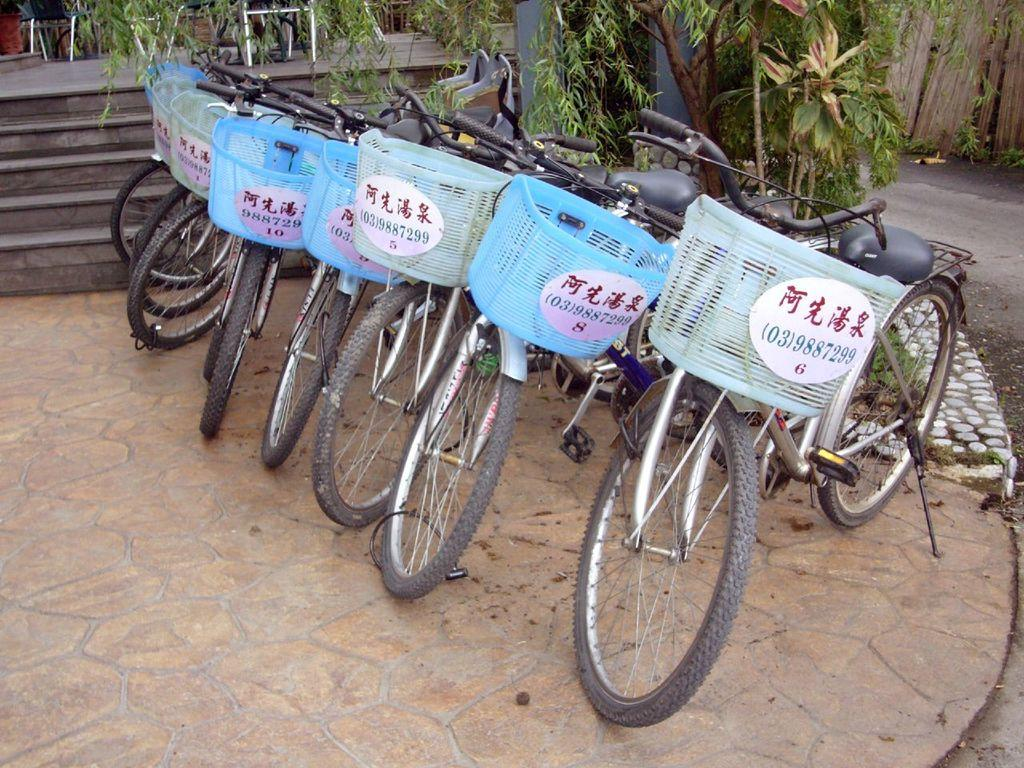What type of vehicles are present in the image? There are bicycles in the image. What is unique about the bicycles in the image? The bicycles have text on the baskets. What type of natural elements can be seen in the image? There are trees in the image. What type of furniture is present in the image? There are chairs in the image. What type of barrier can be seen on the right side of the image? There appears to be a wooden fence on the right side of the image. What is the birth date of the person who observed the bicycles in the image? There is no person observing the bicycles in the image, and therefore no birth date can be determined. 